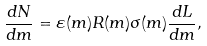Convert formula to latex. <formula><loc_0><loc_0><loc_500><loc_500>\frac { d N } { d m } = \varepsilon ( m ) R ( m ) \sigma ( m ) \frac { d L } { d m } ,</formula> 